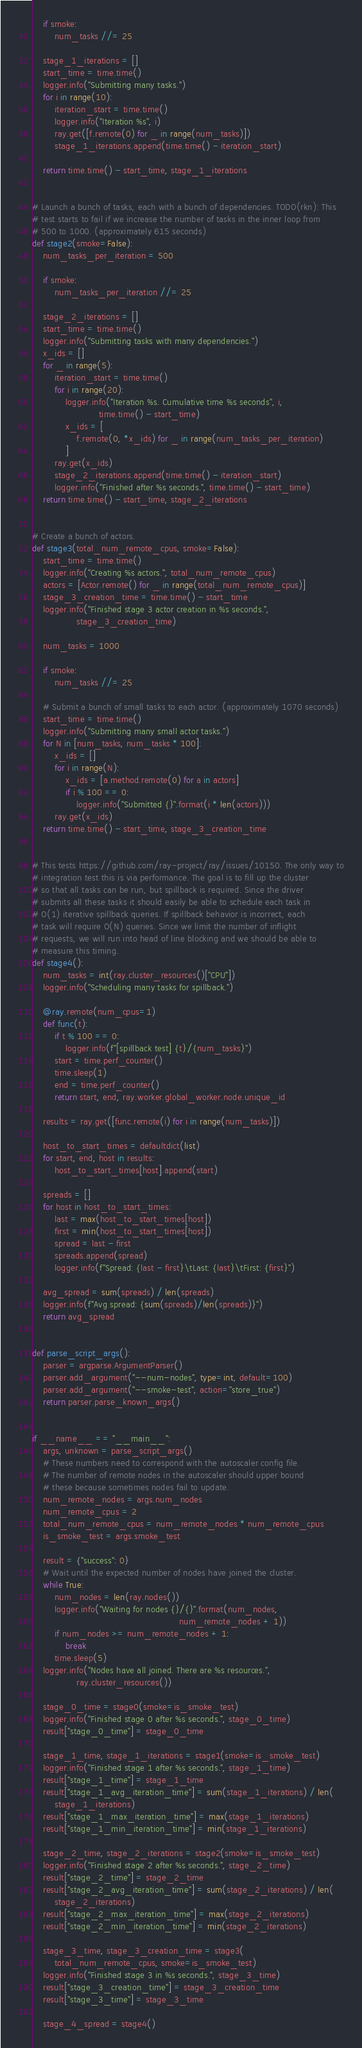Convert code to text. <code><loc_0><loc_0><loc_500><loc_500><_Python_>    if smoke:
        num_tasks //= 25

    stage_1_iterations = []
    start_time = time.time()
    logger.info("Submitting many tasks.")
    for i in range(10):
        iteration_start = time.time()
        logger.info("Iteration %s", i)
        ray.get([f.remote(0) for _ in range(num_tasks)])
        stage_1_iterations.append(time.time() - iteration_start)

    return time.time() - start_time, stage_1_iterations


# Launch a bunch of tasks, each with a bunch of dependencies. TODO(rkn): This
# test starts to fail if we increase the number of tasks in the inner loop from
# 500 to 1000. (approximately 615 seconds)
def stage2(smoke=False):
    num_tasks_per_iteration = 500

    if smoke:
        num_tasks_per_iteration //= 25

    stage_2_iterations = []
    start_time = time.time()
    logger.info("Submitting tasks with many dependencies.")
    x_ids = []
    for _ in range(5):
        iteration_start = time.time()
        for i in range(20):
            logger.info("Iteration %s. Cumulative time %s seconds", i,
                        time.time() - start_time)
            x_ids = [
                f.remote(0, *x_ids) for _ in range(num_tasks_per_iteration)
            ]
        ray.get(x_ids)
        stage_2_iterations.append(time.time() - iteration_start)
        logger.info("Finished after %s seconds.", time.time() - start_time)
    return time.time() - start_time, stage_2_iterations


# Create a bunch of actors.
def stage3(total_num_remote_cpus, smoke=False):
    start_time = time.time()
    logger.info("Creating %s actors.", total_num_remote_cpus)
    actors = [Actor.remote() for _ in range(total_num_remote_cpus)]
    stage_3_creation_time = time.time() - start_time
    logger.info("Finished stage 3 actor creation in %s seconds.",
                stage_3_creation_time)

    num_tasks = 1000

    if smoke:
        num_tasks //= 25

    # Submit a bunch of small tasks to each actor. (approximately 1070 seconds)
    start_time = time.time()
    logger.info("Submitting many small actor tasks.")
    for N in [num_tasks, num_tasks * 100]:
        x_ids = []
        for i in range(N):
            x_ids = [a.method.remote(0) for a in actors]
            if i % 100 == 0:
                logger.info("Submitted {}".format(i * len(actors)))
        ray.get(x_ids)
    return time.time() - start_time, stage_3_creation_time


# This tests https://github.com/ray-project/ray/issues/10150. The only way to
# integration test this is via performance. The goal is to fill up the cluster
# so that all tasks can be run, but spillback is required. Since the driver
# submits all these tasks it should easily be able to schedule each task in
# O(1) iterative spillback queries. If spillback behavior is incorrect, each
# task will require O(N) queries. Since we limit the number of inflight
# requests, we will run into head of line blocking and we should be able to
# measure this timing.
def stage4():
    num_tasks = int(ray.cluster_resources()["CPU"])
    logger.info("Scheduling many tasks for spillback.")

    @ray.remote(num_cpus=1)
    def func(t):
        if t % 100 == 0:
            logger.info(f"[spillback test] {t}/{num_tasks}")
        start = time.perf_counter()
        time.sleep(1)
        end = time.perf_counter()
        return start, end, ray.worker.global_worker.node.unique_id

    results = ray.get([func.remote(i) for i in range(num_tasks)])

    host_to_start_times = defaultdict(list)
    for start, end, host in results:
        host_to_start_times[host].append(start)

    spreads = []
    for host in host_to_start_times:
        last = max(host_to_start_times[host])
        first = min(host_to_start_times[host])
        spread = last - first
        spreads.append(spread)
        logger.info(f"Spread: {last - first}\tLast: {last}\tFirst: {first}")

    avg_spread = sum(spreads) / len(spreads)
    logger.info(f"Avg spread: {sum(spreads)/len(spreads)}")
    return avg_spread


def parse_script_args():
    parser = argparse.ArgumentParser()
    parser.add_argument("--num-nodes", type=int, default=100)
    parser.add_argument("--smoke-test", action="store_true")
    return parser.parse_known_args()


if __name__ == "__main__":
    args, unknown = parse_script_args()
    # These numbers need to correspond with the autoscaler config file.
    # The number of remote nodes in the autoscaler should upper bound
    # these because sometimes nodes fail to update.
    num_remote_nodes = args.num_nodes
    num_remote_cpus = 2
    total_num_remote_cpus = num_remote_nodes * num_remote_cpus
    is_smoke_test = args.smoke_test

    result = {"success": 0}
    # Wait until the expected number of nodes have joined the cluster.
    while True:
        num_nodes = len(ray.nodes())
        logger.info("Waiting for nodes {}/{}".format(num_nodes,
                                                     num_remote_nodes + 1))
        if num_nodes >= num_remote_nodes + 1:
            break
        time.sleep(5)
    logger.info("Nodes have all joined. There are %s resources.",
                ray.cluster_resources())

    stage_0_time = stage0(smoke=is_smoke_test)
    logger.info("Finished stage 0 after %s seconds.", stage_0_time)
    result["stage_0_time"] = stage_0_time

    stage_1_time, stage_1_iterations = stage1(smoke=is_smoke_test)
    logger.info("Finished stage 1 after %s seconds.", stage_1_time)
    result["stage_1_time"] = stage_1_time
    result["stage_1_avg_iteration_time"] = sum(stage_1_iterations) / len(
        stage_1_iterations)
    result["stage_1_max_iteration_time"] = max(stage_1_iterations)
    result["stage_1_min_iteration_time"] = min(stage_1_iterations)

    stage_2_time, stage_2_iterations = stage2(smoke=is_smoke_test)
    logger.info("Finished stage 2 after %s seconds.", stage_2_time)
    result["stage_2_time"] = stage_2_time
    result["stage_2_avg_iteration_time"] = sum(stage_2_iterations) / len(
        stage_2_iterations)
    result["stage_2_max_iteration_time"] = max(stage_2_iterations)
    result["stage_2_min_iteration_time"] = min(stage_2_iterations)

    stage_3_time, stage_3_creation_time = stage3(
        total_num_remote_cpus, smoke=is_smoke_test)
    logger.info("Finished stage 3 in %s seconds.", stage_3_time)
    result["stage_3_creation_time"] = stage_3_creation_time
    result["stage_3_time"] = stage_3_time

    stage_4_spread = stage4()</code> 